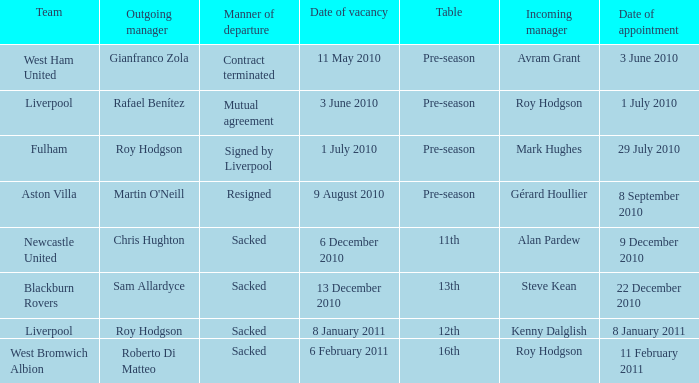What is the vacancy date for the liverpool team in a table named pre-season? 3 June 2010. 